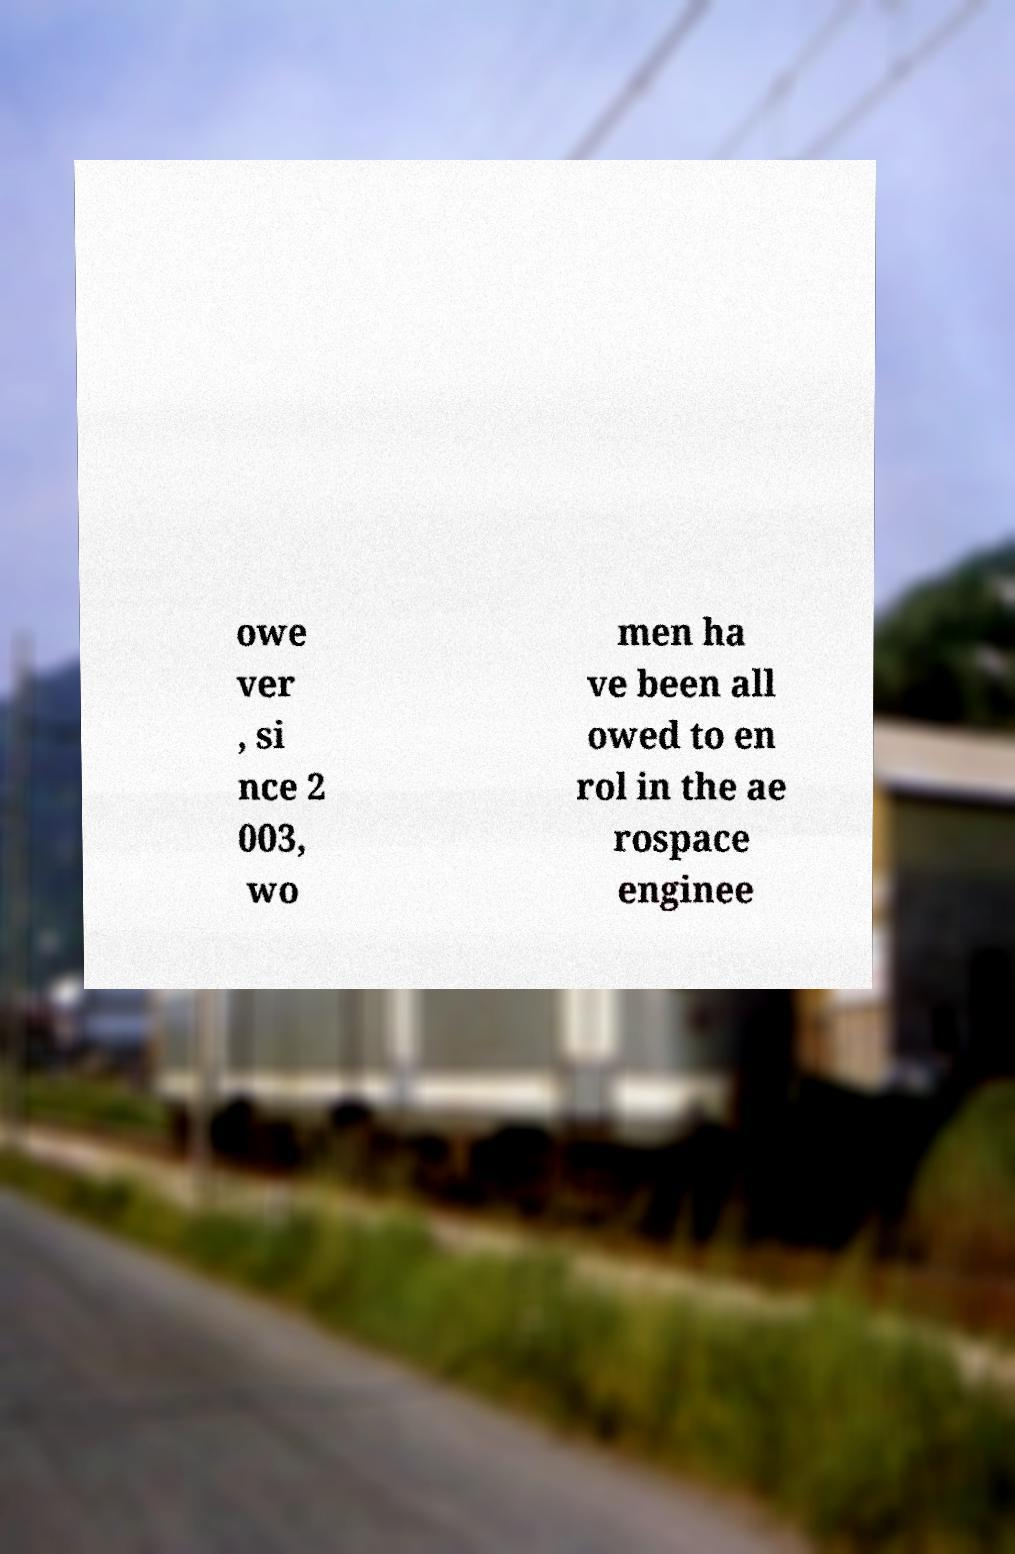Can you accurately transcribe the text from the provided image for me? owe ver , si nce 2 003, wo men ha ve been all owed to en rol in the ae rospace enginee 